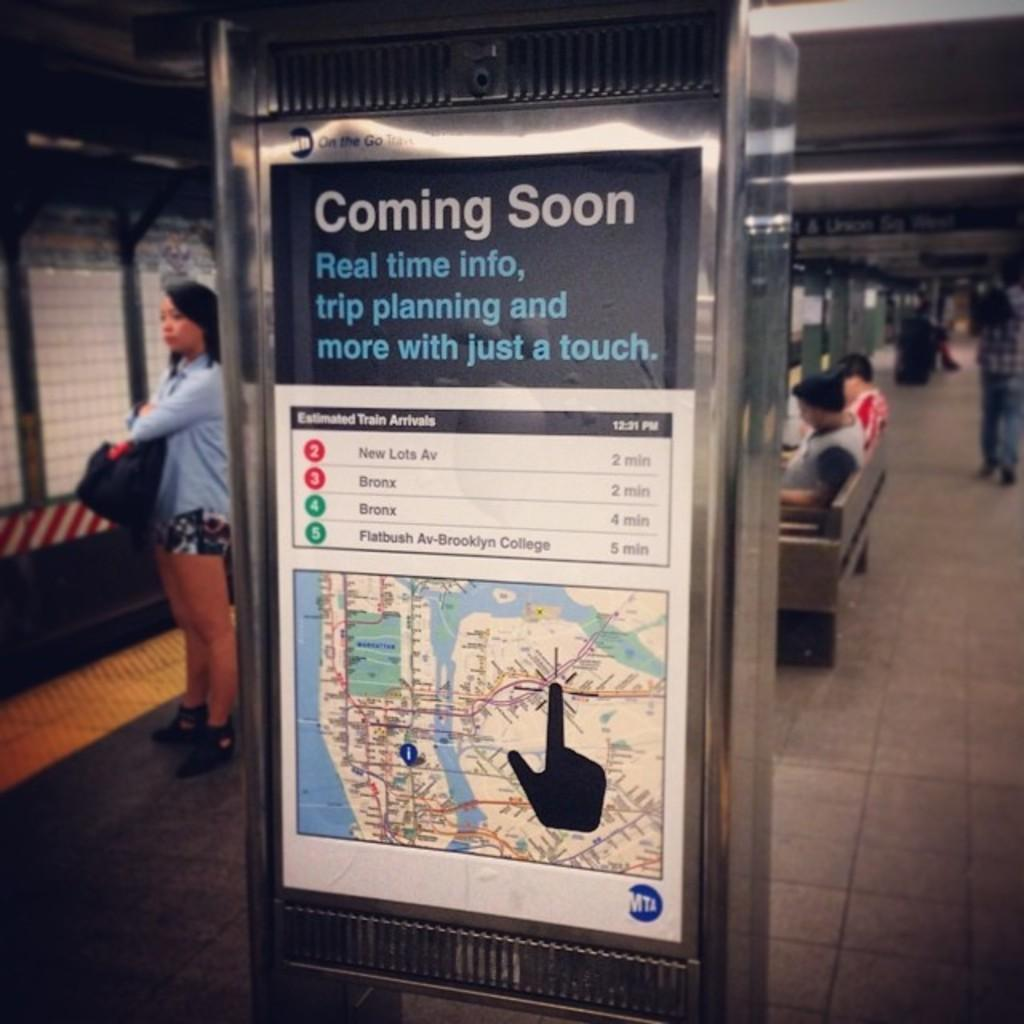<image>
Provide a brief description of the given image. Trains to New Lots Avenue and the Bronx will both be arriving in two minutes. 